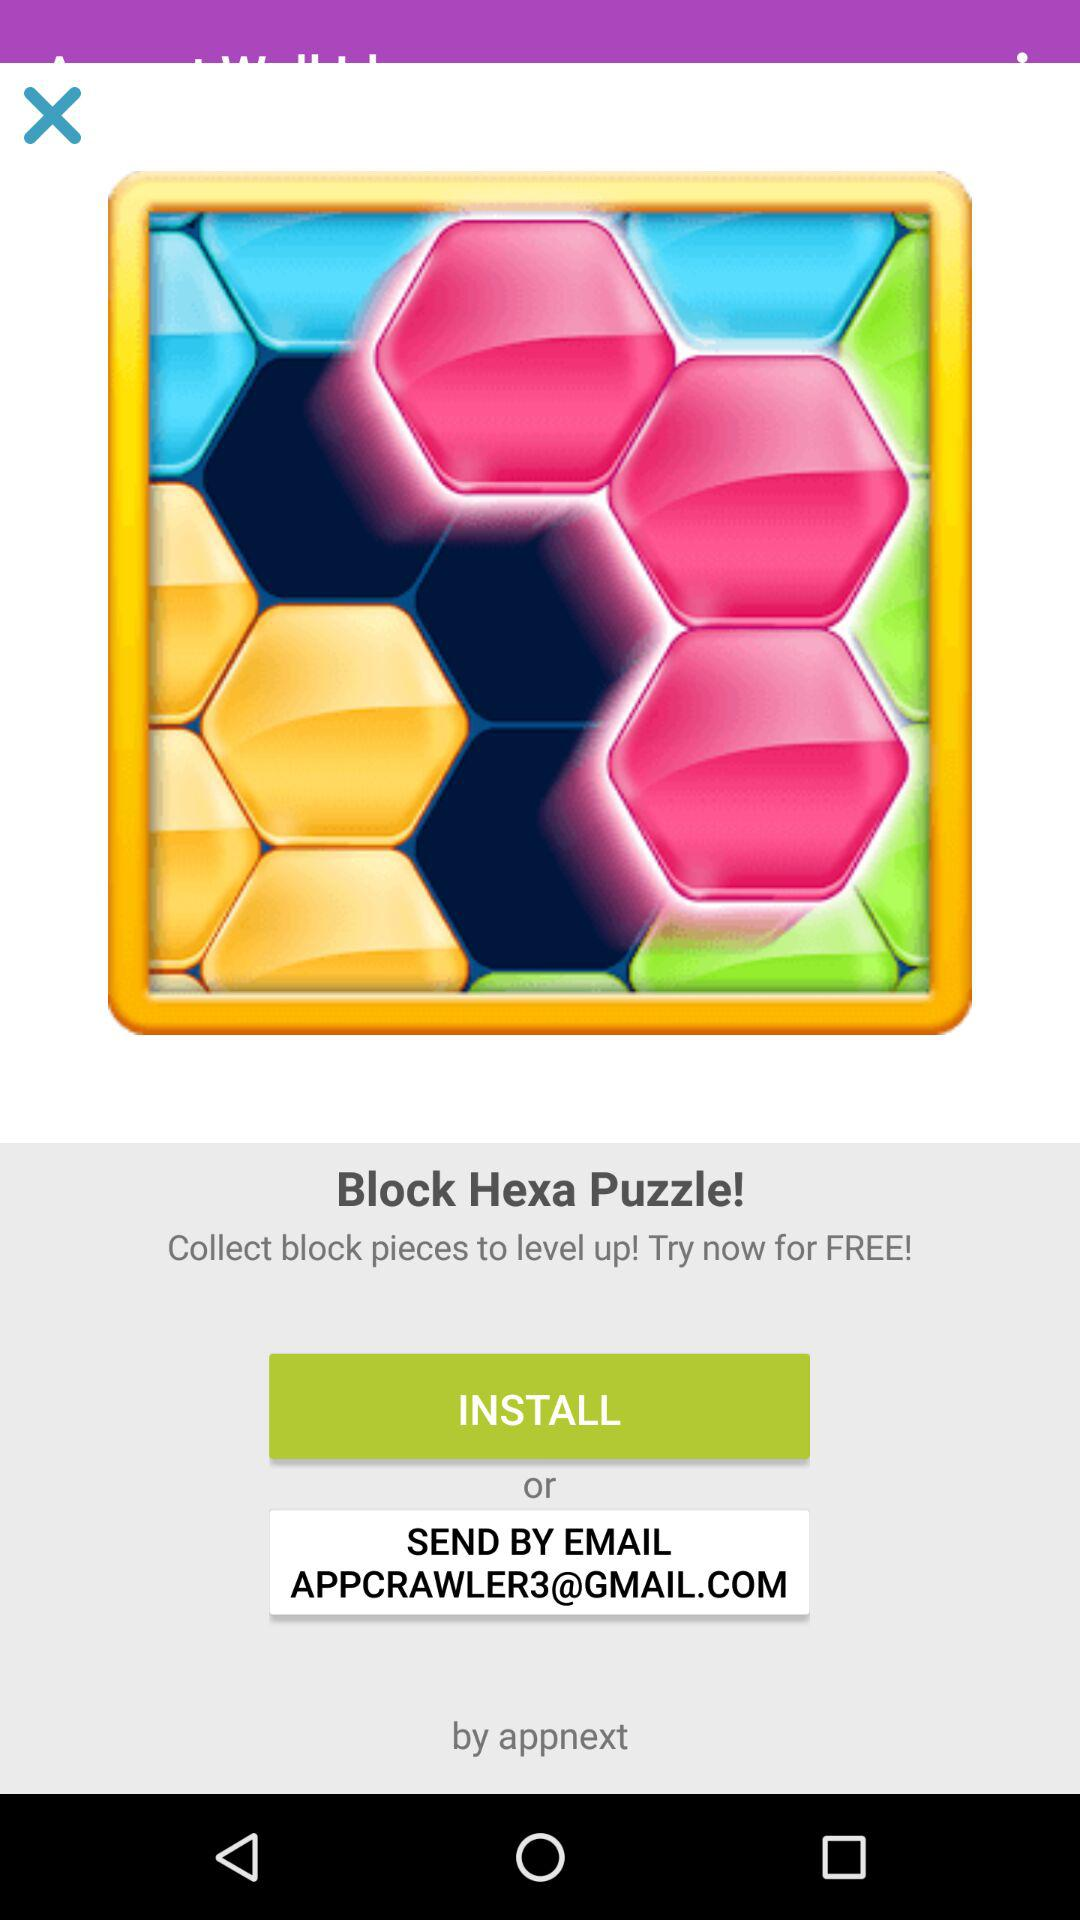What email ID is given to send? The email ID given to send is APPCRAWLER3@GMAIL.COM. 